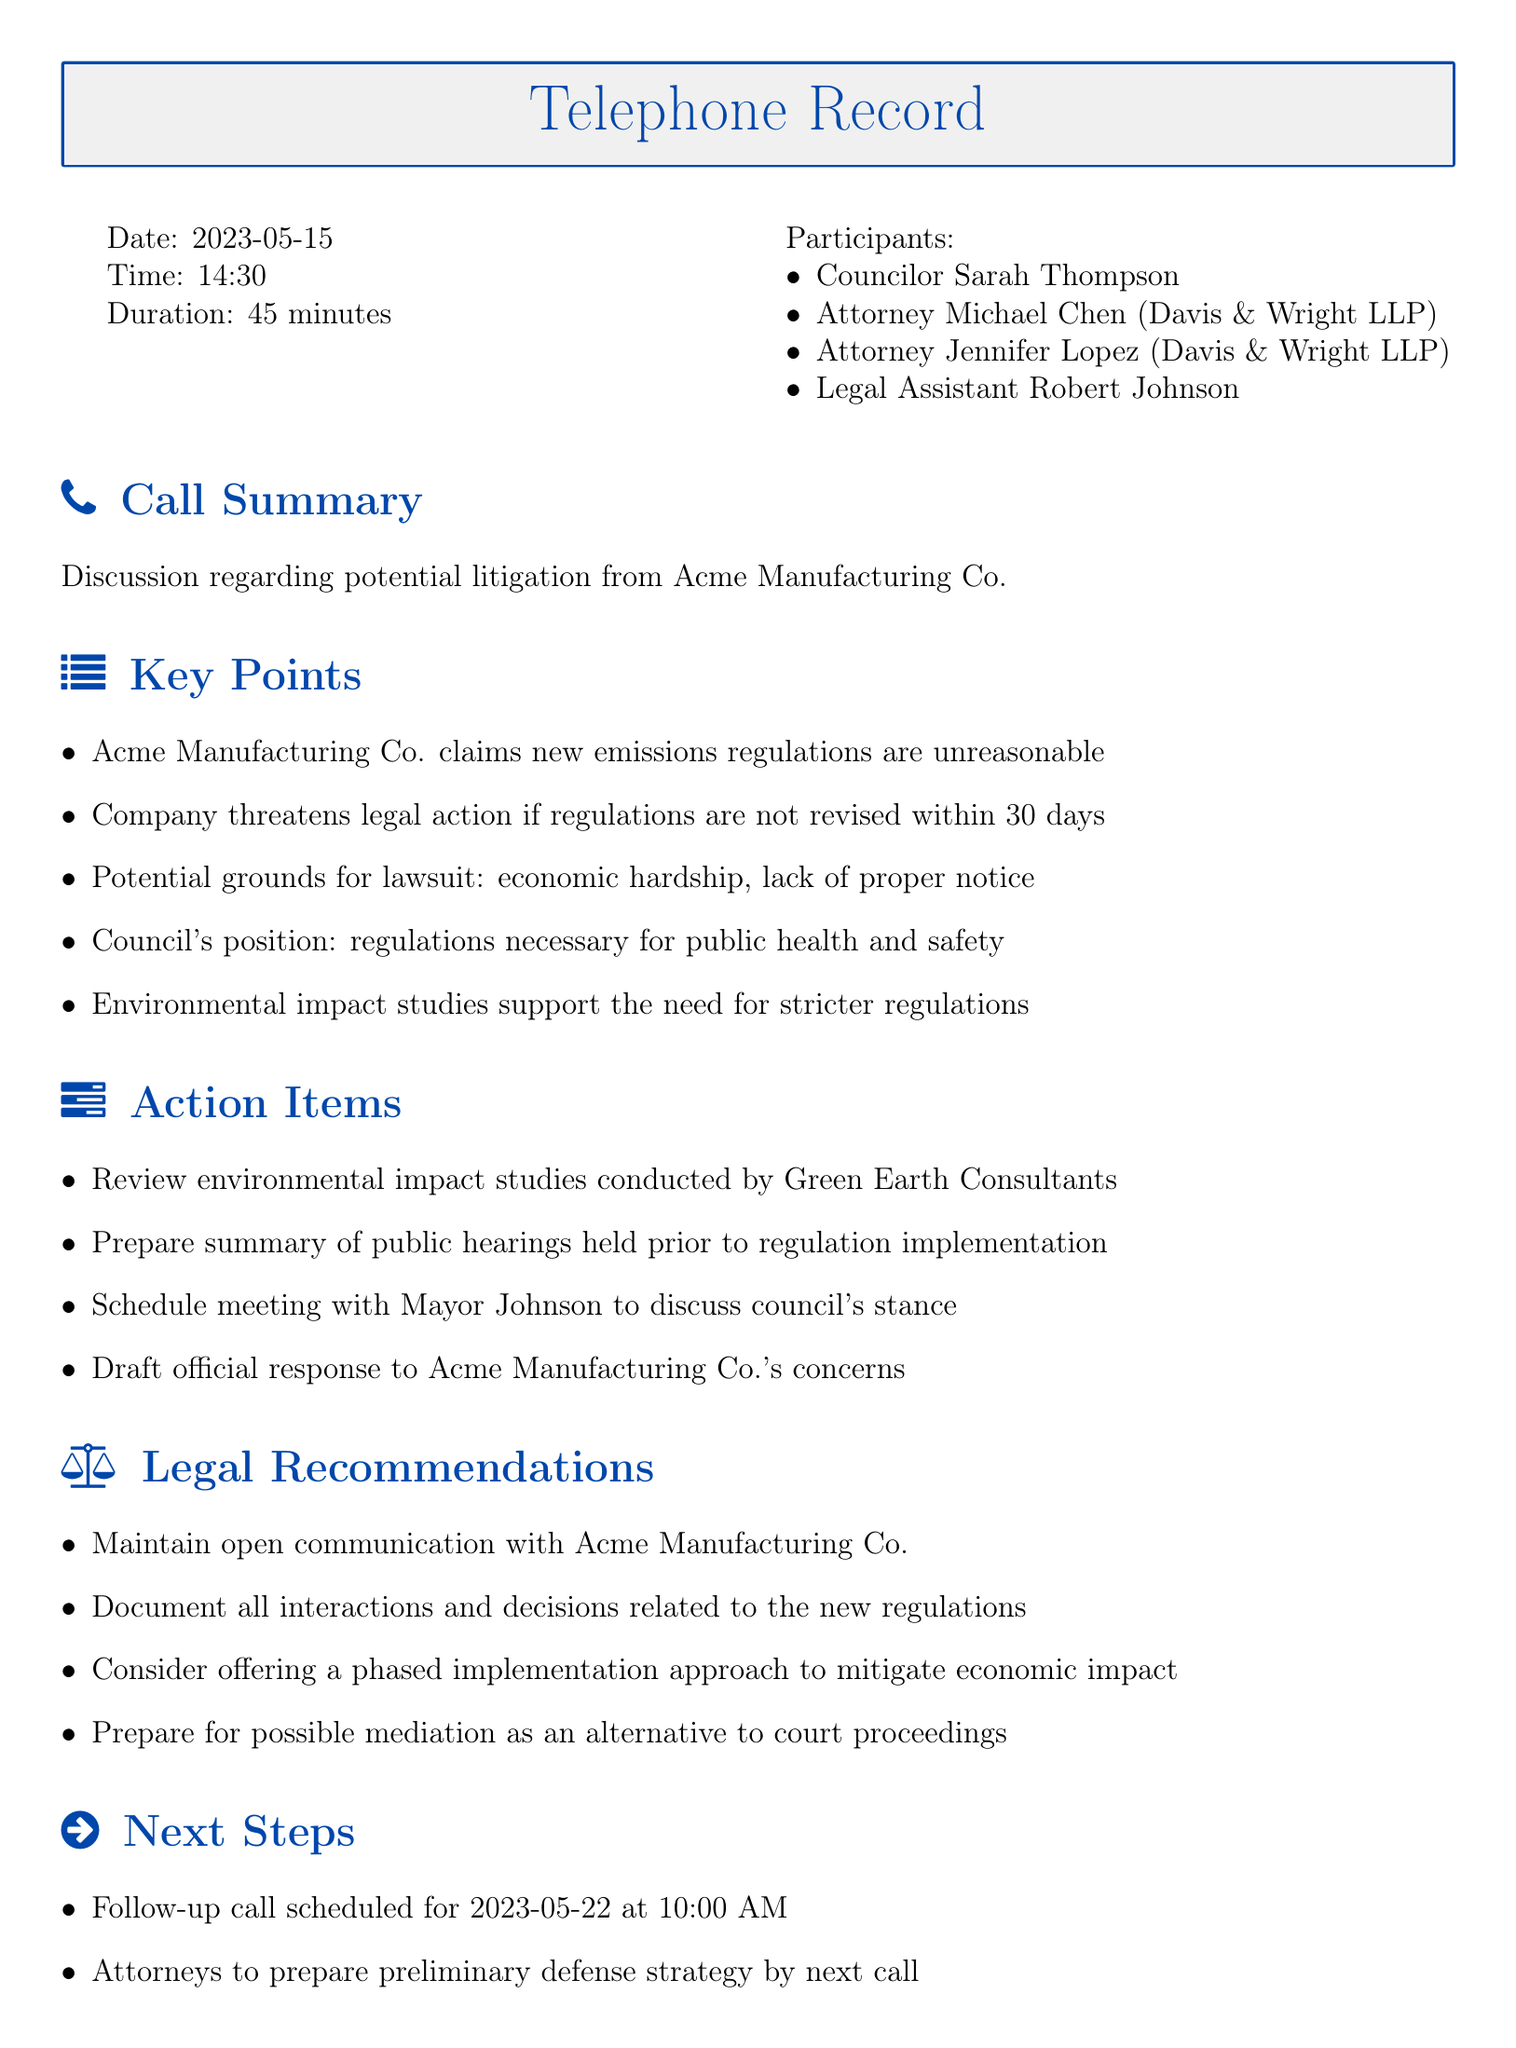what is the date of the call? The date is explicitly stated at the beginning of the document as 2023-05-15.
Answer: 2023-05-15 who participated in the call? The participants are listed under the Participants section, including Councilor Sarah Thompson, Attorney Michael Chen, Attorney Jennifer Lopez, and Legal Assistant Robert Johnson.
Answer: Councilor Sarah Thompson, Attorney Michael Chen, Attorney Jennifer Lopez, Legal Assistant Robert Johnson how long did the call last? The duration of the call is mentioned as 45 minutes.
Answer: 45 minutes what company is threatening legal action? The company name is mentioned at the start of the call summary. It is Acme Manufacturing Co.
Answer: Acme Manufacturing Co what is one of the potential grounds for the lawsuit? The document lists potential grounds, including economic hardship and lack of proper notice.
Answer: economic hardship what action item involves environmental studies? One action item tasks to review environmental impact studies conducted by Green Earth Consultants.
Answer: Review environmental impact studies when is the follow-up call scheduled? The follow-up call date and time are specifically mentioned in the Next Steps section as 2023-05-22 at 10:00 AM.
Answer: 2023-05-22 at 10:00 AM what is a legal recommendation provided? The document includes several legal recommendations, one being to maintain open communication with Acme Manufacturing Co.
Answer: Maintain open communication with Acme Manufacturing Co 